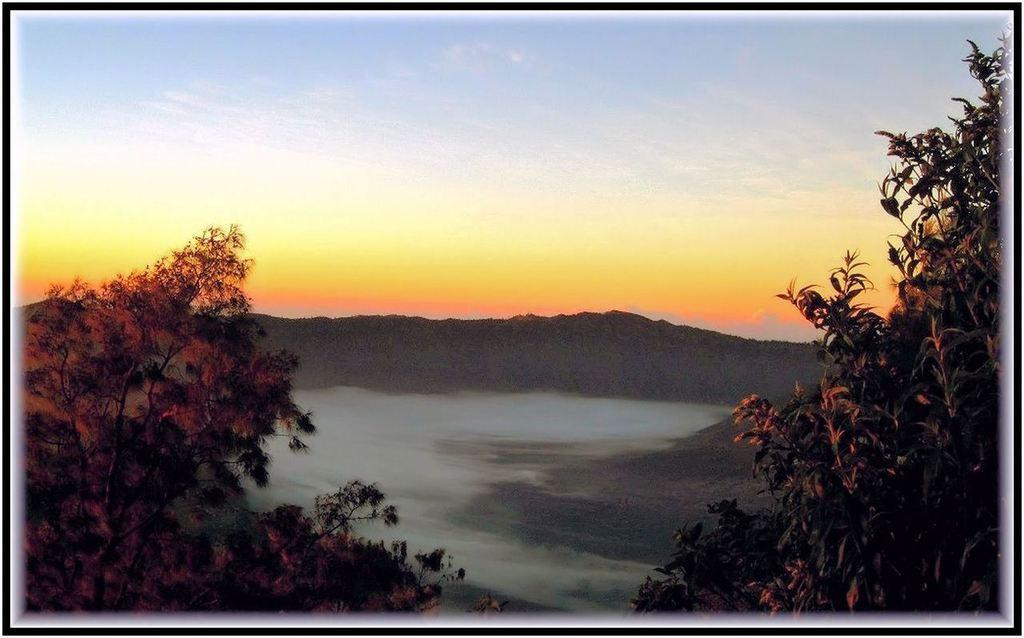What type of scenery is depicted in the image? The image contains a beautiful scenery. What natural elements can be seen in the image? There are trees and mountains in the image. What part of the natural environment is visible in the background of the image? The sky is visible in the background of the image. How would you describe the view of the sky in the image? The view of the sky is pleasant. How does the image compare to a painting of a similar scene? The image is not being compared to a painting in this context, as the facts provided only describe the image itself. 